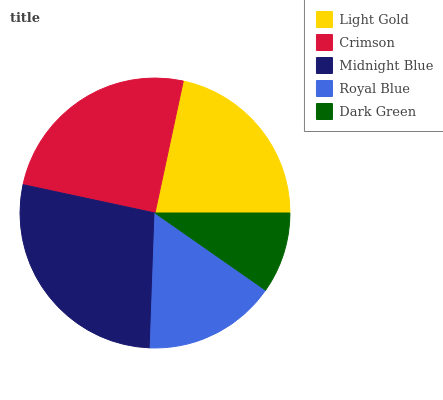Is Dark Green the minimum?
Answer yes or no. Yes. Is Midnight Blue the maximum?
Answer yes or no. Yes. Is Crimson the minimum?
Answer yes or no. No. Is Crimson the maximum?
Answer yes or no. No. Is Crimson greater than Light Gold?
Answer yes or no. Yes. Is Light Gold less than Crimson?
Answer yes or no. Yes. Is Light Gold greater than Crimson?
Answer yes or no. No. Is Crimson less than Light Gold?
Answer yes or no. No. Is Light Gold the high median?
Answer yes or no. Yes. Is Light Gold the low median?
Answer yes or no. Yes. Is Dark Green the high median?
Answer yes or no. No. Is Dark Green the low median?
Answer yes or no. No. 